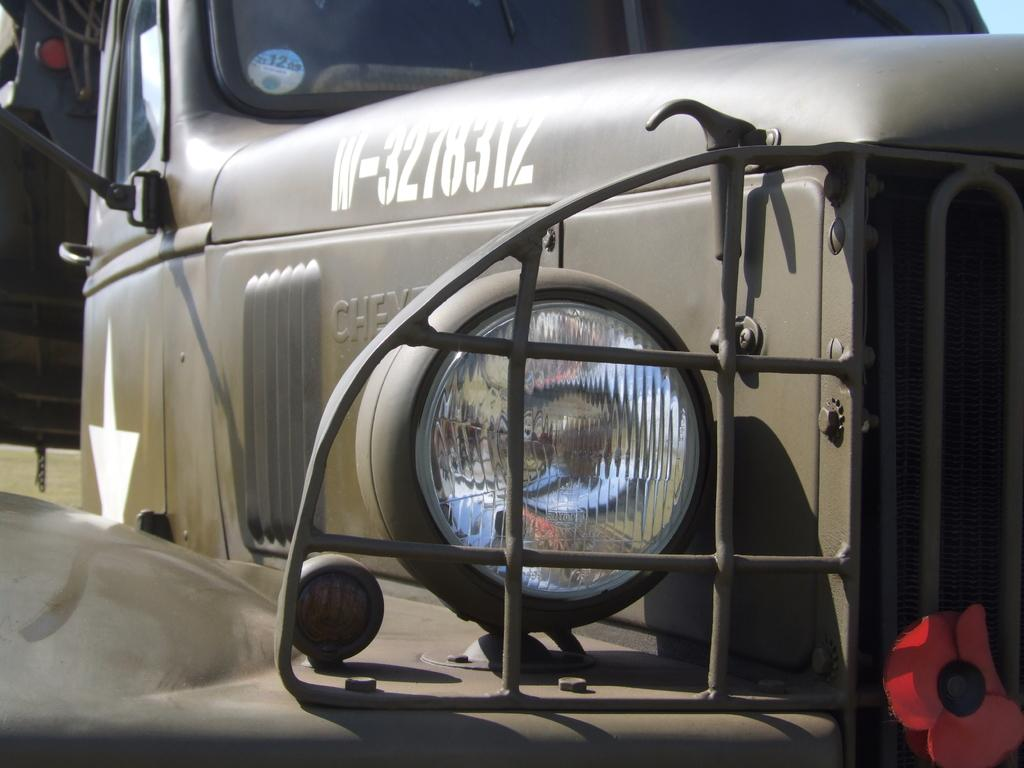What is the main subject of the picture? The main subject of the picture is a vehicle. Can you describe a specific feature of the vehicle? Yes, the vehicle has a headlight in the middle. Are there any decorations or additional elements on the vehicle? Yes, there is a flower on the right corner of the vehicle. What type of coat is the vehicle wearing in the image? Vehicles do not wear coats, as they are inanimate objects. The question is not relevant to the image. 